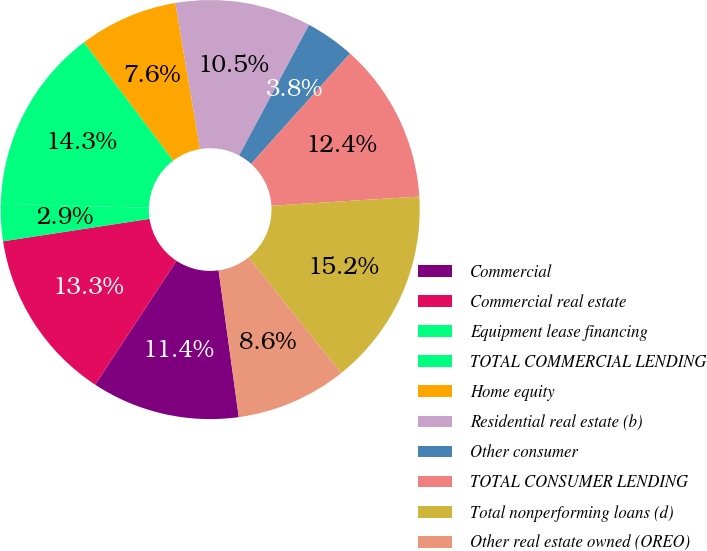Convert chart. <chart><loc_0><loc_0><loc_500><loc_500><pie_chart><fcel>Commercial<fcel>Commercial real estate<fcel>Equipment lease financing<fcel>TOTAL COMMERCIAL LENDING<fcel>Home equity<fcel>Residential real estate (b)<fcel>Other consumer<fcel>TOTAL CONSUMER LENDING<fcel>Total nonperforming loans (d)<fcel>Other real estate owned (OREO)<nl><fcel>11.43%<fcel>13.33%<fcel>2.86%<fcel>14.28%<fcel>7.62%<fcel>10.48%<fcel>3.81%<fcel>12.38%<fcel>15.24%<fcel>8.57%<nl></chart> 